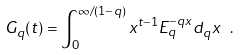<formula> <loc_0><loc_0><loc_500><loc_500>\ G _ { q } ( t ) = \int _ { 0 } ^ { \infty / ( 1 - q ) } x ^ { t - 1 } E _ { q } ^ { - q x } d _ { q } x \ .</formula> 